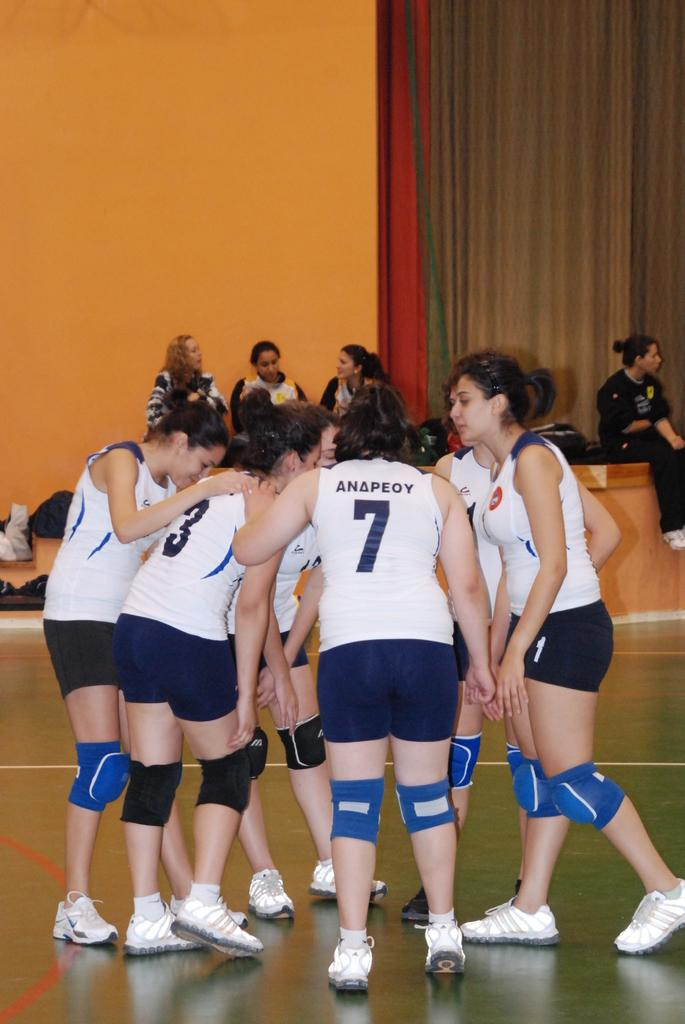<image>
Render a clear and concise summary of the photo. Player number 7 in the center of a huddle between volleyball players. 